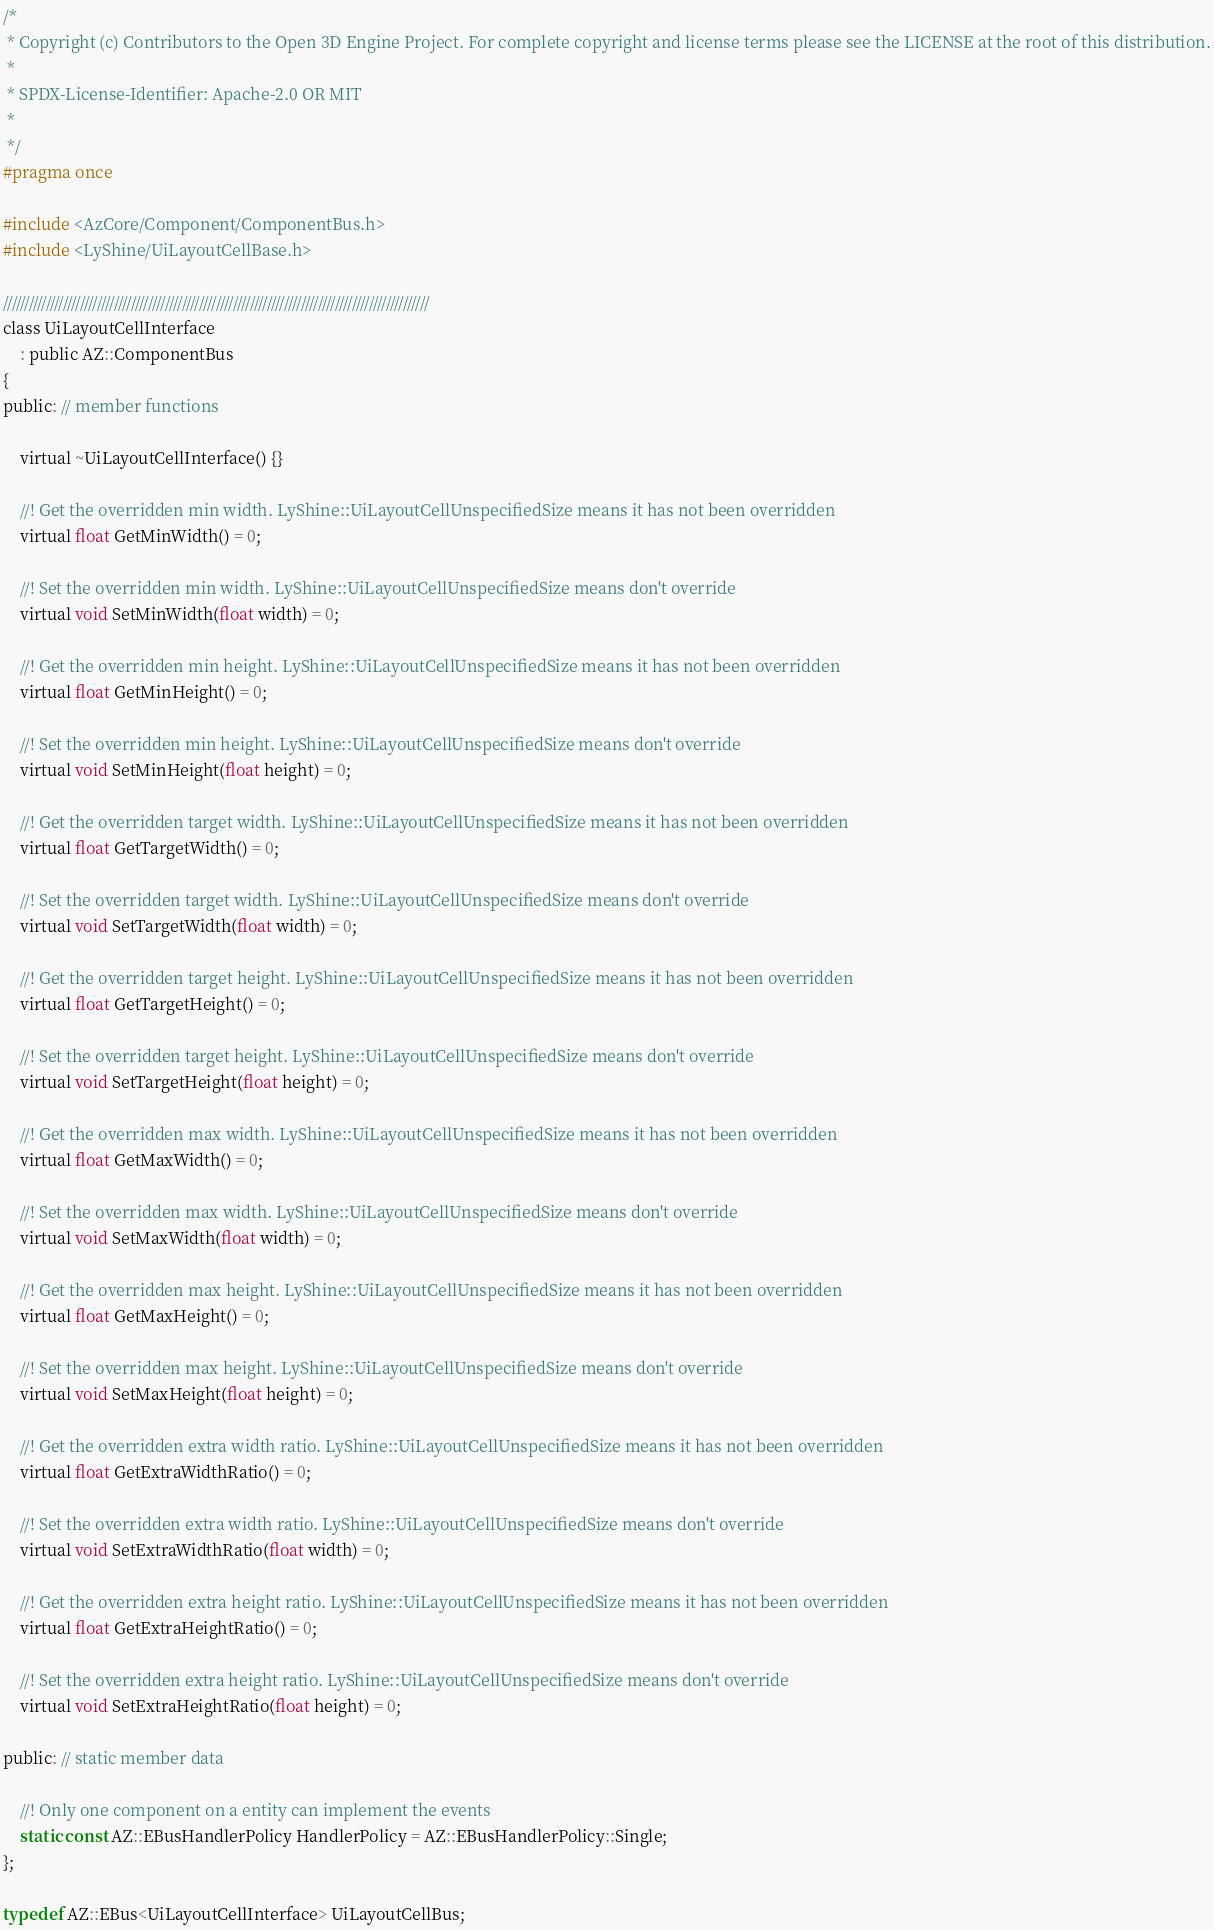Convert code to text. <code><loc_0><loc_0><loc_500><loc_500><_C_>/*
 * Copyright (c) Contributors to the Open 3D Engine Project. For complete copyright and license terms please see the LICENSE at the root of this distribution.
 * 
 * SPDX-License-Identifier: Apache-2.0 OR MIT
 *
 */
#pragma once

#include <AzCore/Component/ComponentBus.h>
#include <LyShine/UiLayoutCellBase.h>

////////////////////////////////////////////////////////////////////////////////////////////////////
class UiLayoutCellInterface
    : public AZ::ComponentBus
{
public: // member functions

    virtual ~UiLayoutCellInterface() {}

    //! Get the overridden min width. LyShine::UiLayoutCellUnspecifiedSize means it has not been overridden
    virtual float GetMinWidth() = 0;

    //! Set the overridden min width. LyShine::UiLayoutCellUnspecifiedSize means don't override
    virtual void SetMinWidth(float width) = 0;

    //! Get the overridden min height. LyShine::UiLayoutCellUnspecifiedSize means it has not been overridden
    virtual float GetMinHeight() = 0;

    //! Set the overridden min height. LyShine::UiLayoutCellUnspecifiedSize means don't override
    virtual void SetMinHeight(float height) = 0;

    //! Get the overridden target width. LyShine::UiLayoutCellUnspecifiedSize means it has not been overridden
    virtual float GetTargetWidth() = 0;

    //! Set the overridden target width. LyShine::UiLayoutCellUnspecifiedSize means don't override
    virtual void SetTargetWidth(float width) = 0;

    //! Get the overridden target height. LyShine::UiLayoutCellUnspecifiedSize means it has not been overridden
    virtual float GetTargetHeight() = 0;

    //! Set the overridden target height. LyShine::UiLayoutCellUnspecifiedSize means don't override
    virtual void SetTargetHeight(float height) = 0;

    //! Get the overridden max width. LyShine::UiLayoutCellUnspecifiedSize means it has not been overridden
    virtual float GetMaxWidth() = 0;

    //! Set the overridden max width. LyShine::UiLayoutCellUnspecifiedSize means don't override
    virtual void SetMaxWidth(float width) = 0;

    //! Get the overridden max height. LyShine::UiLayoutCellUnspecifiedSize means it has not been overridden
    virtual float GetMaxHeight() = 0;

    //! Set the overridden max height. LyShine::UiLayoutCellUnspecifiedSize means don't override
    virtual void SetMaxHeight(float height) = 0;

    //! Get the overridden extra width ratio. LyShine::UiLayoutCellUnspecifiedSize means it has not been overridden
    virtual float GetExtraWidthRatio() = 0;

    //! Set the overridden extra width ratio. LyShine::UiLayoutCellUnspecifiedSize means don't override
    virtual void SetExtraWidthRatio(float width) = 0;

    //! Get the overridden extra height ratio. LyShine::UiLayoutCellUnspecifiedSize means it has not been overridden
    virtual float GetExtraHeightRatio() = 0;

    //! Set the overridden extra height ratio. LyShine::UiLayoutCellUnspecifiedSize means don't override
    virtual void SetExtraHeightRatio(float height) = 0;

public: // static member data

    //! Only one component on a entity can implement the events
    static const AZ::EBusHandlerPolicy HandlerPolicy = AZ::EBusHandlerPolicy::Single;
};

typedef AZ::EBus<UiLayoutCellInterface> UiLayoutCellBus;
</code> 